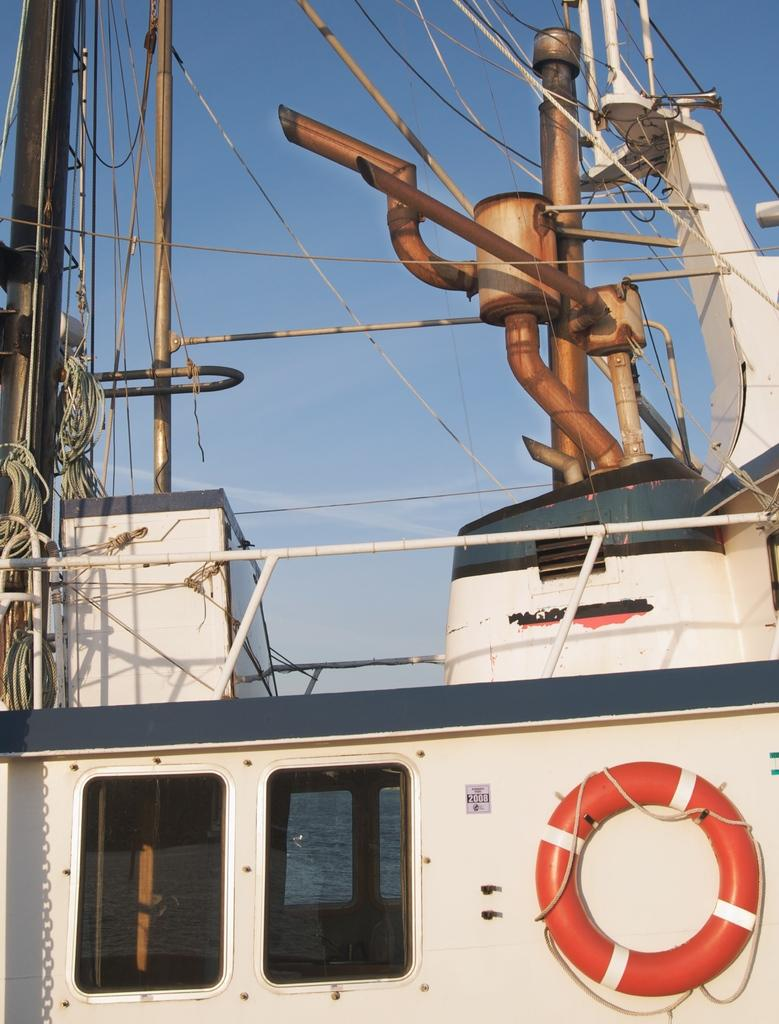What is the main subject of the picture? The main subject of the picture is a ship. What specific features can be seen on the ship? The ship has ropes, windows, and poles. Are there any other objects on the ship? Yes, there are other objects on the ship. What can be seen in the background of the picture? The sky is visible in the background of the picture. Where is the throne located on the ship in the image? There is no throne present on the ship in the image. What type of control is needed to operate the ship in the image? The image does not show the ship in operation, so it is not possible to determine what type of control is needed. 